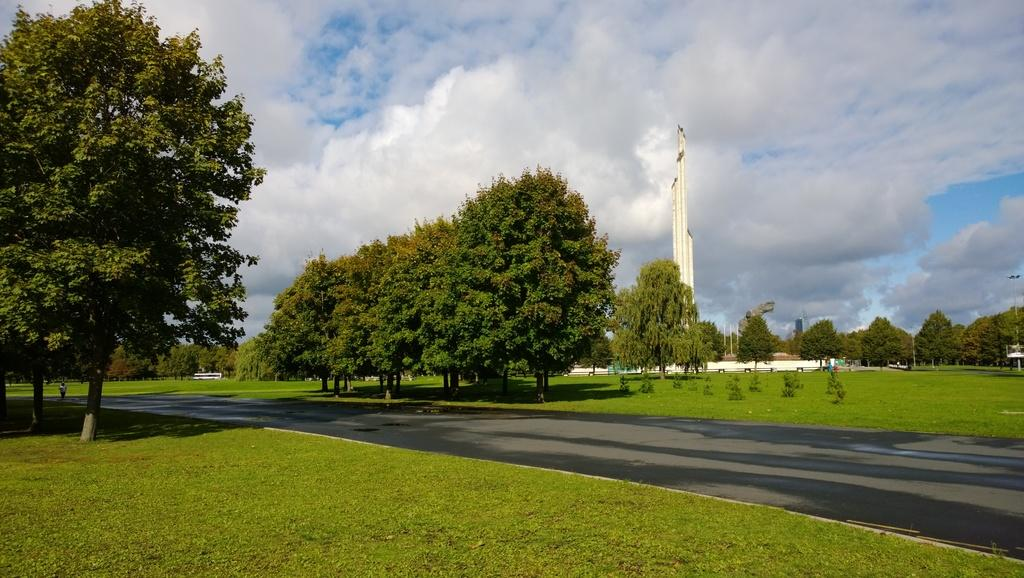What type of vegetation can be seen in the image? There are trees and bushes in the image. What can be seen on the road in the image? There are motor vehicles and persons standing on the road. What structure is visible in the image? There is a tower in the image. What are the poles used for in the image? The poles are likely used for supporting wires or other infrastructure. What type of lighting is present in the image? There are flood lights in the image. What is visible in the background of the image? The sky is visible in the background of the image, with clouds present. How many yaks are grazing in the bushes in the image? There are no yaks present in the image; it features trees, bushes, motor vehicles, persons, a tower, poles, flood lights, and a sky with clouds. What type of growth is visible on the persons standing on the road in the image? There is no specific growth visible on the persons standing on the road in the image. 